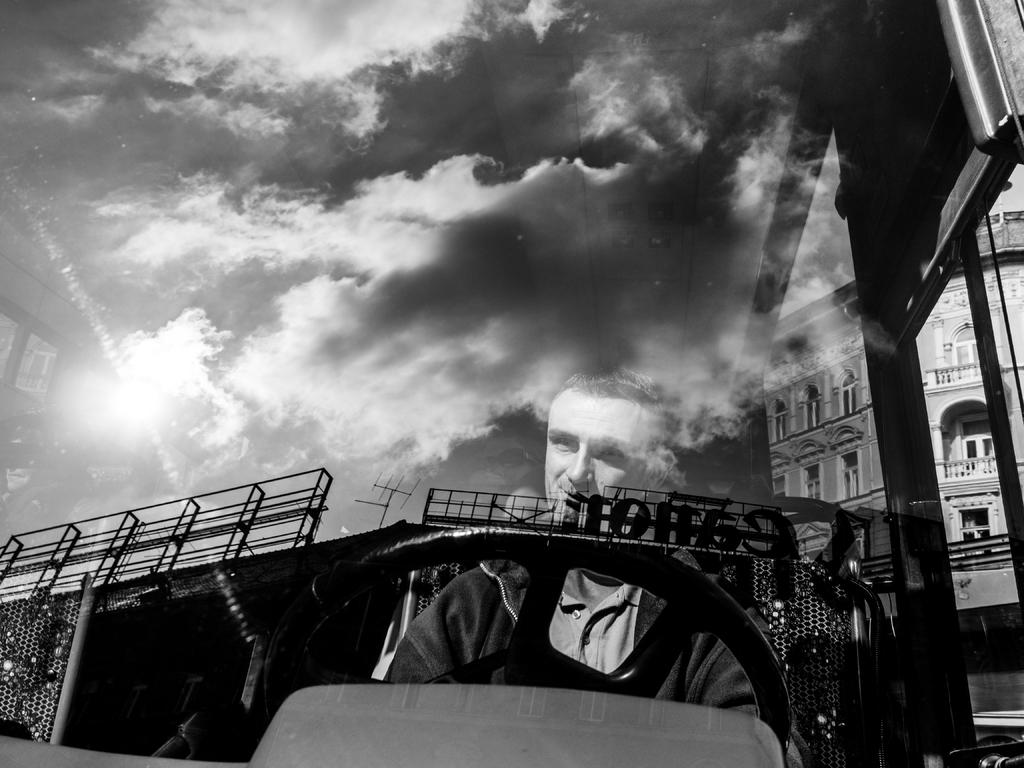Who or what is inside the vehicle in the image? There is a person in the vehicle. What can be seen on the glass of the vehicle? There is a reflection of clouds on the glass, and a name board is visible on the glass. What type of structure can be seen in the image? There is a building in the image. What type of cord is being used to hang the toothpaste in the image? There is no toothpaste or cord present in the image. 